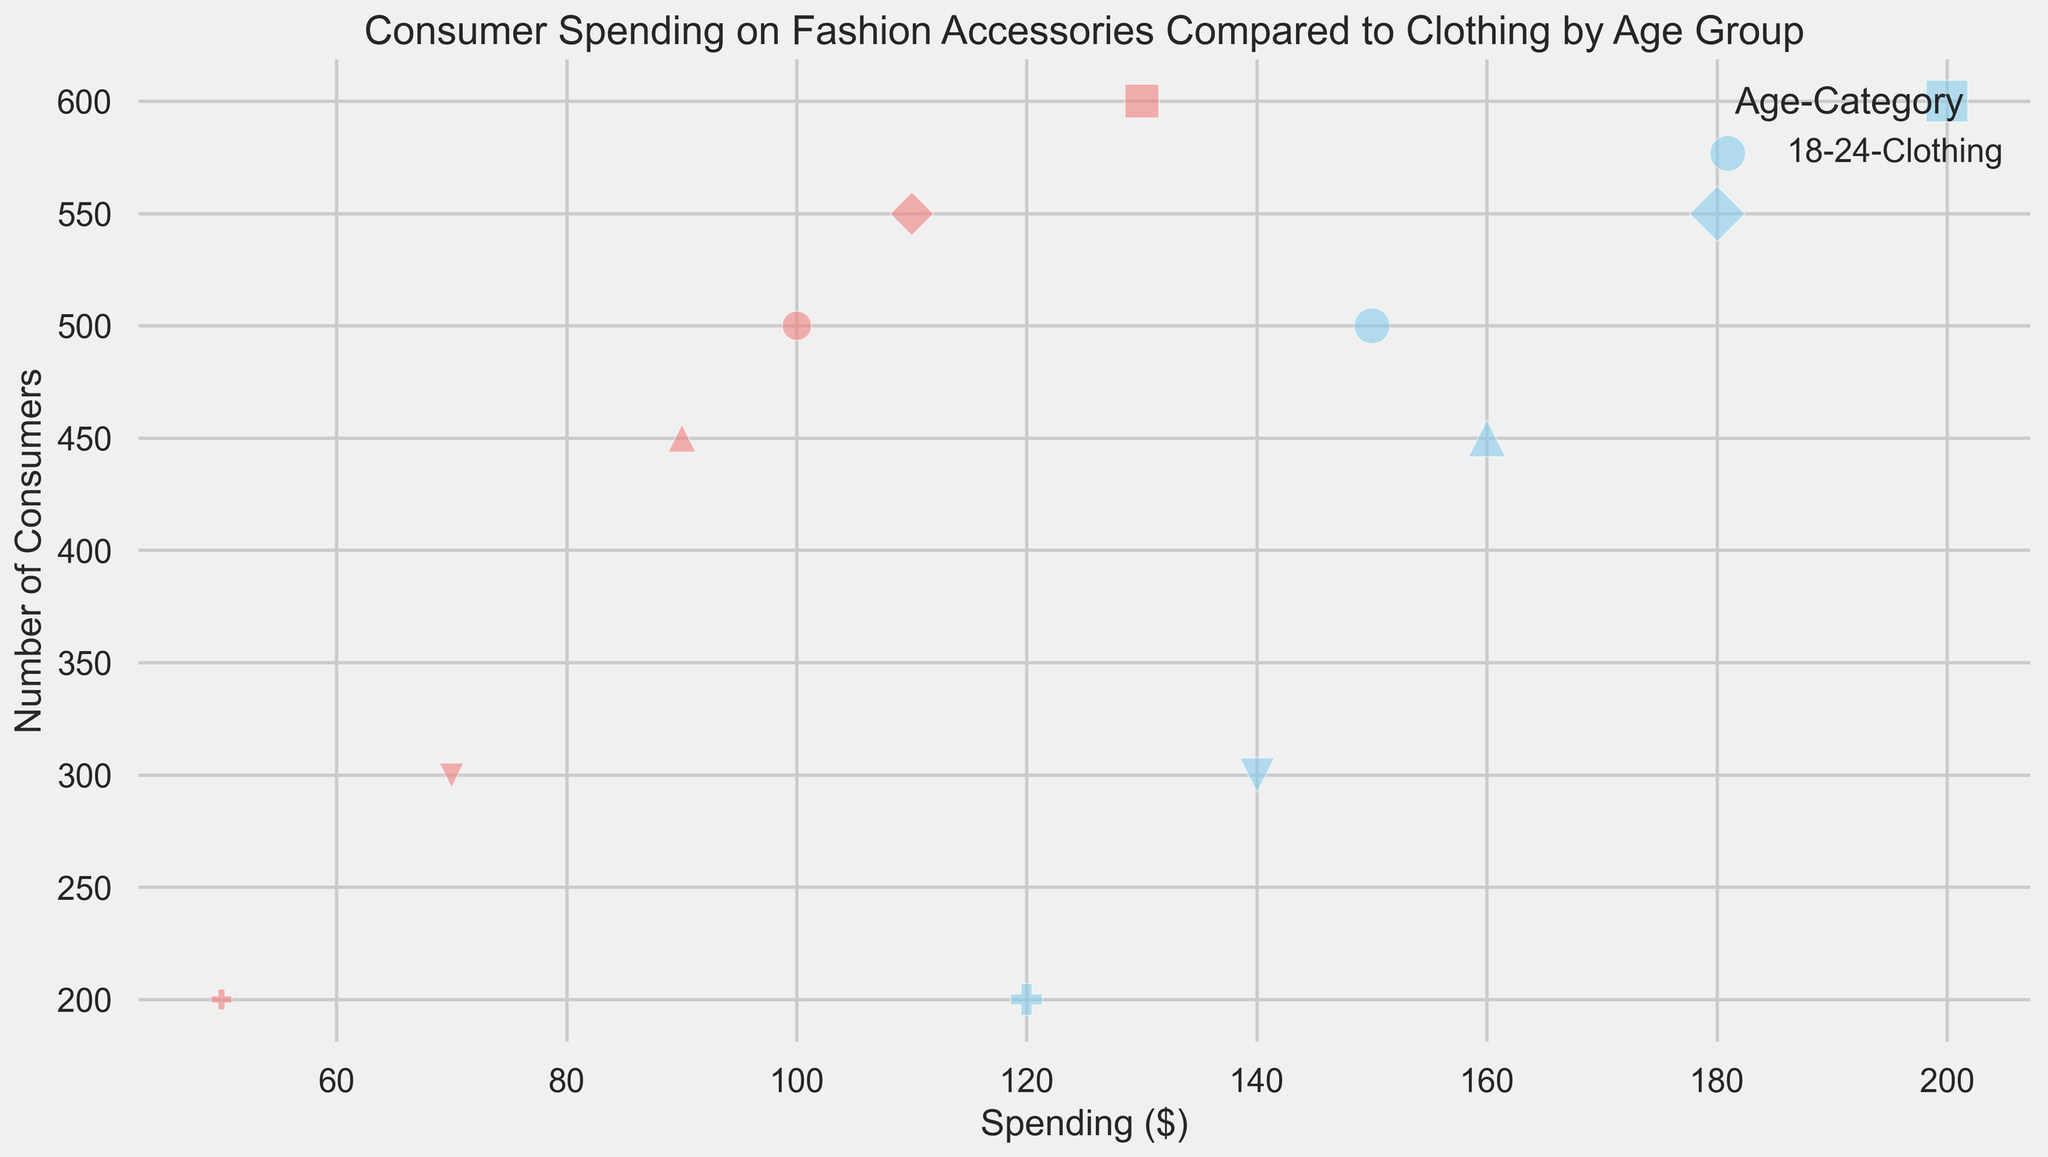What age group spends the most on clothing? From the chart, look for the age group with the highest spending value on clothing. The 25-34 age group has the highest spending of $200 on clothing.
Answer: 25-34 What is the total spending on accessories for all age groups combined? Add up the spending on accessories for each age group: 100 + 130 + 110 + 90 + 70 + 50 = 550.
Answer: 550 How does the number of consumers in the 18-24 age group compare to the 65+ age group? The number of consumers in the 18-24 age group is 500 for both categories and 200 in the 65+ age group for both categories. The 18-24 age group has more consumers than the 65+ age group.
Answer: More Which category has a higher spending in the 35-44 age group, and by how much? In the 35-44 age group, spending is $180 on clothing and $110 on accessories. Clothing spending is $180 - $110 = $70 higher than accessories.
Answer: Clothing by $70 What is the average spending on clothing across all age groups? Add up the spending on clothing for all age groups and divide by the number of age groups: (150 + 200 + 180 + 160 + 140 + 120) / 6 = 950 / 6 ≈ 158.33.
Answer: ≈ 158.33 Which age group has the smallest difference in spending between clothing and accessories? Calculate the difference in spending for each age group: 
- 18-24: 150 - 100 = 50
- 25-34: 200 - 130 = 70
- 35-44: 180 - 110 = 70
- 45-54: 160 - 90 = 70
- 55-64: 140 - 70 = 70
- 65+: 120 - 50 = 70.
The smallest difference is for the 18-24 age group with a difference of $50.
Answer: 18-24 How does the spending on clothing for the 45-54 age group compare to the 25-34 age group? The spending on clothing for the 45-54 age group is $160, whereas for the 25-34 age group it is $200. Spending is less in the 45-54 compared to the 25-34.
Answer: Less Which category shows a trend of decreasing spending with increasing age? Look at the spending patterns for both categories across age groups. Accessories spending decreases consistently as the age increases.
Answer: Accessories What is the total number of consumers for clothing from all age groups? Add up the number of consumers for clothing across all age groups: 500 + 600 + 550 + 450 + 300 + 200 = 2600.
Answer: 2600 Which age group has the highest total spending (clothing + accessories)? Calculate the total spending for each age group:
- 18-24: 150 + 100 = 250
- 25-34: 200 + 130 = 330
- 35-44: 180 + 110 = 290
- 45-54: 160 + 90 = 250
- 55-64: 140 + 70 = 210
- 65+: 120 + 50 = 170.
The age group 25-34 has the highest total spending of $330.
Answer: 25-34 